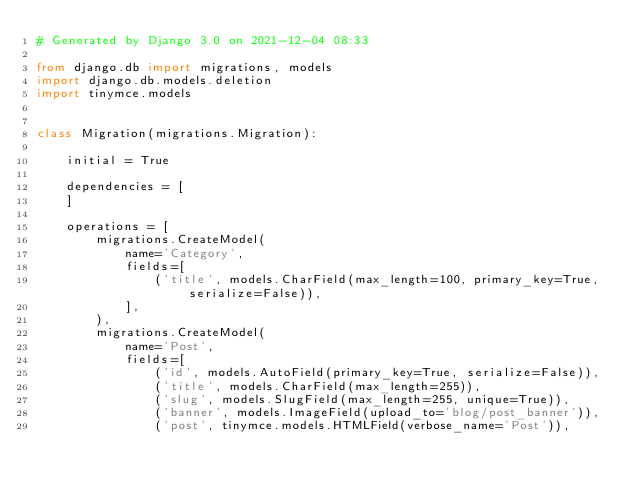Convert code to text. <code><loc_0><loc_0><loc_500><loc_500><_Python_># Generated by Django 3.0 on 2021-12-04 08:33

from django.db import migrations, models
import django.db.models.deletion
import tinymce.models


class Migration(migrations.Migration):

    initial = True

    dependencies = [
    ]

    operations = [
        migrations.CreateModel(
            name='Category',
            fields=[
                ('title', models.CharField(max_length=100, primary_key=True, serialize=False)),
            ],
        ),
        migrations.CreateModel(
            name='Post',
            fields=[
                ('id', models.AutoField(primary_key=True, serialize=False)),
                ('title', models.CharField(max_length=255)),
                ('slug', models.SlugField(max_length=255, unique=True)),
                ('banner', models.ImageField(upload_to='blog/post_banner')),
                ('post', tinymce.models.HTMLField(verbose_name='Post')),</code> 